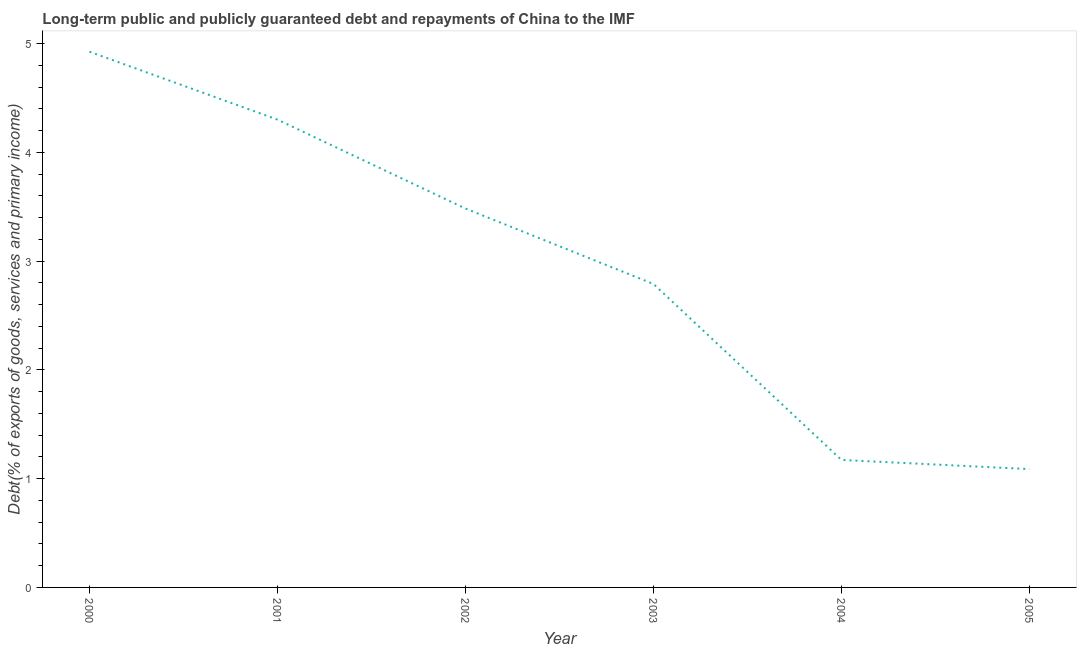What is the debt service in 2000?
Give a very brief answer. 4.93. Across all years, what is the maximum debt service?
Provide a succinct answer. 4.93. Across all years, what is the minimum debt service?
Offer a terse response. 1.09. In which year was the debt service maximum?
Keep it short and to the point. 2000. In which year was the debt service minimum?
Your response must be concise. 2005. What is the sum of the debt service?
Make the answer very short. 17.76. What is the difference between the debt service in 2002 and 2005?
Give a very brief answer. 2.4. What is the average debt service per year?
Keep it short and to the point. 2.96. What is the median debt service?
Provide a short and direct response. 3.14. In how many years, is the debt service greater than 3.8 %?
Your answer should be very brief. 2. What is the ratio of the debt service in 2002 to that in 2005?
Offer a very short reply. 3.2. What is the difference between the highest and the second highest debt service?
Provide a succinct answer. 0.62. Is the sum of the debt service in 2002 and 2005 greater than the maximum debt service across all years?
Provide a succinct answer. No. What is the difference between the highest and the lowest debt service?
Offer a terse response. 3.84. Does the debt service monotonically increase over the years?
Offer a terse response. No. Are the values on the major ticks of Y-axis written in scientific E-notation?
Make the answer very short. No. What is the title of the graph?
Provide a succinct answer. Long-term public and publicly guaranteed debt and repayments of China to the IMF. What is the label or title of the Y-axis?
Give a very brief answer. Debt(% of exports of goods, services and primary income). What is the Debt(% of exports of goods, services and primary income) of 2000?
Offer a terse response. 4.93. What is the Debt(% of exports of goods, services and primary income) in 2001?
Provide a short and direct response. 4.3. What is the Debt(% of exports of goods, services and primary income) of 2002?
Your answer should be compact. 3.48. What is the Debt(% of exports of goods, services and primary income) of 2003?
Keep it short and to the point. 2.79. What is the Debt(% of exports of goods, services and primary income) of 2004?
Your answer should be very brief. 1.17. What is the Debt(% of exports of goods, services and primary income) in 2005?
Provide a short and direct response. 1.09. What is the difference between the Debt(% of exports of goods, services and primary income) in 2000 and 2001?
Offer a very short reply. 0.62. What is the difference between the Debt(% of exports of goods, services and primary income) in 2000 and 2002?
Ensure brevity in your answer.  1.44. What is the difference between the Debt(% of exports of goods, services and primary income) in 2000 and 2003?
Ensure brevity in your answer.  2.14. What is the difference between the Debt(% of exports of goods, services and primary income) in 2000 and 2004?
Provide a short and direct response. 3.75. What is the difference between the Debt(% of exports of goods, services and primary income) in 2000 and 2005?
Provide a succinct answer. 3.84. What is the difference between the Debt(% of exports of goods, services and primary income) in 2001 and 2002?
Your answer should be very brief. 0.82. What is the difference between the Debt(% of exports of goods, services and primary income) in 2001 and 2003?
Your answer should be very brief. 1.51. What is the difference between the Debt(% of exports of goods, services and primary income) in 2001 and 2004?
Give a very brief answer. 3.13. What is the difference between the Debt(% of exports of goods, services and primary income) in 2001 and 2005?
Provide a short and direct response. 3.21. What is the difference between the Debt(% of exports of goods, services and primary income) in 2002 and 2003?
Your response must be concise. 0.69. What is the difference between the Debt(% of exports of goods, services and primary income) in 2002 and 2004?
Your answer should be compact. 2.31. What is the difference between the Debt(% of exports of goods, services and primary income) in 2002 and 2005?
Your response must be concise. 2.4. What is the difference between the Debt(% of exports of goods, services and primary income) in 2003 and 2004?
Your response must be concise. 1.62. What is the difference between the Debt(% of exports of goods, services and primary income) in 2003 and 2005?
Your answer should be compact. 1.7. What is the difference between the Debt(% of exports of goods, services and primary income) in 2004 and 2005?
Provide a short and direct response. 0.08. What is the ratio of the Debt(% of exports of goods, services and primary income) in 2000 to that in 2001?
Your response must be concise. 1.15. What is the ratio of the Debt(% of exports of goods, services and primary income) in 2000 to that in 2002?
Your response must be concise. 1.41. What is the ratio of the Debt(% of exports of goods, services and primary income) in 2000 to that in 2003?
Keep it short and to the point. 1.76. What is the ratio of the Debt(% of exports of goods, services and primary income) in 2000 to that in 2004?
Offer a very short reply. 4.2. What is the ratio of the Debt(% of exports of goods, services and primary income) in 2000 to that in 2005?
Your response must be concise. 4.53. What is the ratio of the Debt(% of exports of goods, services and primary income) in 2001 to that in 2002?
Make the answer very short. 1.24. What is the ratio of the Debt(% of exports of goods, services and primary income) in 2001 to that in 2003?
Your answer should be compact. 1.54. What is the ratio of the Debt(% of exports of goods, services and primary income) in 2001 to that in 2004?
Give a very brief answer. 3.67. What is the ratio of the Debt(% of exports of goods, services and primary income) in 2001 to that in 2005?
Make the answer very short. 3.95. What is the ratio of the Debt(% of exports of goods, services and primary income) in 2002 to that in 2003?
Ensure brevity in your answer.  1.25. What is the ratio of the Debt(% of exports of goods, services and primary income) in 2002 to that in 2004?
Provide a short and direct response. 2.97. What is the ratio of the Debt(% of exports of goods, services and primary income) in 2002 to that in 2005?
Make the answer very short. 3.2. What is the ratio of the Debt(% of exports of goods, services and primary income) in 2003 to that in 2004?
Make the answer very short. 2.38. What is the ratio of the Debt(% of exports of goods, services and primary income) in 2003 to that in 2005?
Keep it short and to the point. 2.56. What is the ratio of the Debt(% of exports of goods, services and primary income) in 2004 to that in 2005?
Offer a very short reply. 1.08. 